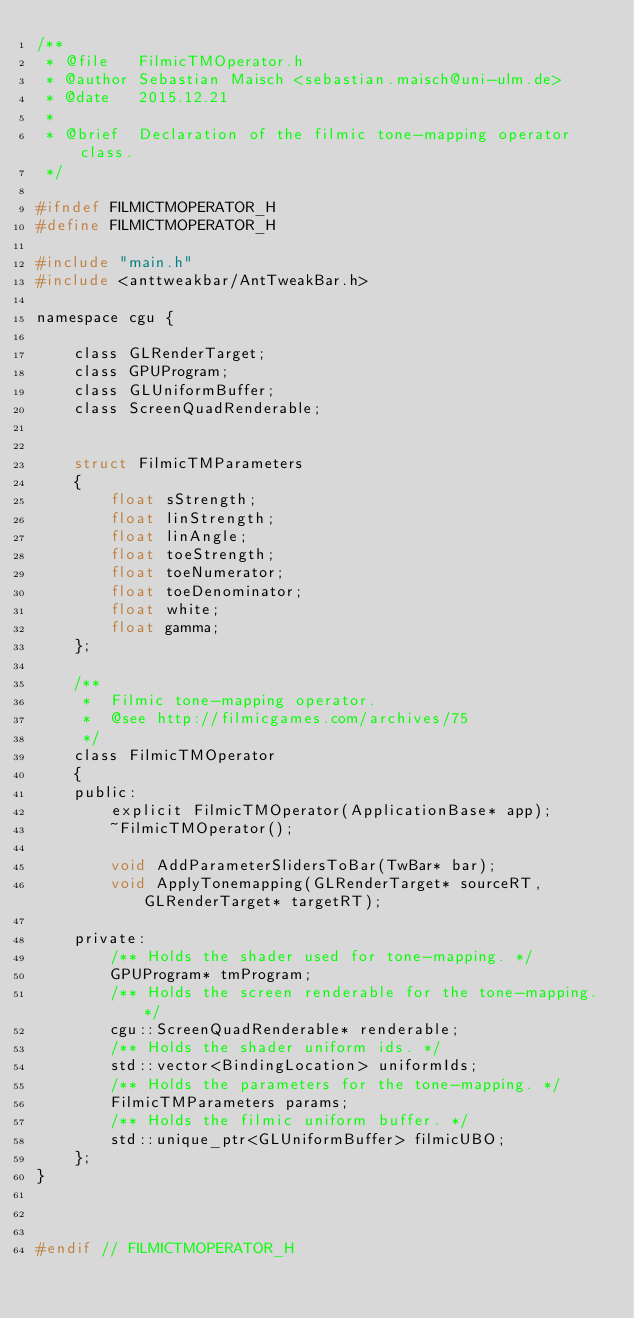<code> <loc_0><loc_0><loc_500><loc_500><_C_>/**
 * @file   FilmicTMOperator.h
 * @author Sebastian Maisch <sebastian.maisch@uni-ulm.de>
 * @date   2015.12.21
 *
 * @brief  Declaration of the filmic tone-mapping operator class.
 */

#ifndef FILMICTMOPERATOR_H
#define FILMICTMOPERATOR_H

#include "main.h"
#include <anttweakbar/AntTweakBar.h>

namespace cgu {

    class GLRenderTarget;
    class GPUProgram;
    class GLUniformBuffer;
    class ScreenQuadRenderable;


    struct FilmicTMParameters
    {
        float sStrength;
        float linStrength;
        float linAngle;
        float toeStrength;
        float toeNumerator;
        float toeDenominator;
        float white;
        float gamma;
    };

    /**
     *  Filmic tone-mapping operator.
     *  @see http://filmicgames.com/archives/75
     */
    class FilmicTMOperator
    {
    public:
        explicit FilmicTMOperator(ApplicationBase* app);
        ~FilmicTMOperator();

        void AddParameterSlidersToBar(TwBar* bar);
        void ApplyTonemapping(GLRenderTarget* sourceRT, GLRenderTarget* targetRT);

    private:
        /** Holds the shader used for tone-mapping. */
        GPUProgram* tmProgram;
        /** Holds the screen renderable for the tone-mapping. */
        cgu::ScreenQuadRenderable* renderable;
        /** Holds the shader uniform ids. */
        std::vector<BindingLocation> uniformIds;
        /** Holds the parameters for the tone-mapping. */
        FilmicTMParameters params;
        /** Holds the filmic uniform buffer. */
        std::unique_ptr<GLUniformBuffer> filmicUBO;
    };
}



#endif // FILMICTMOPERATOR_H
</code> 